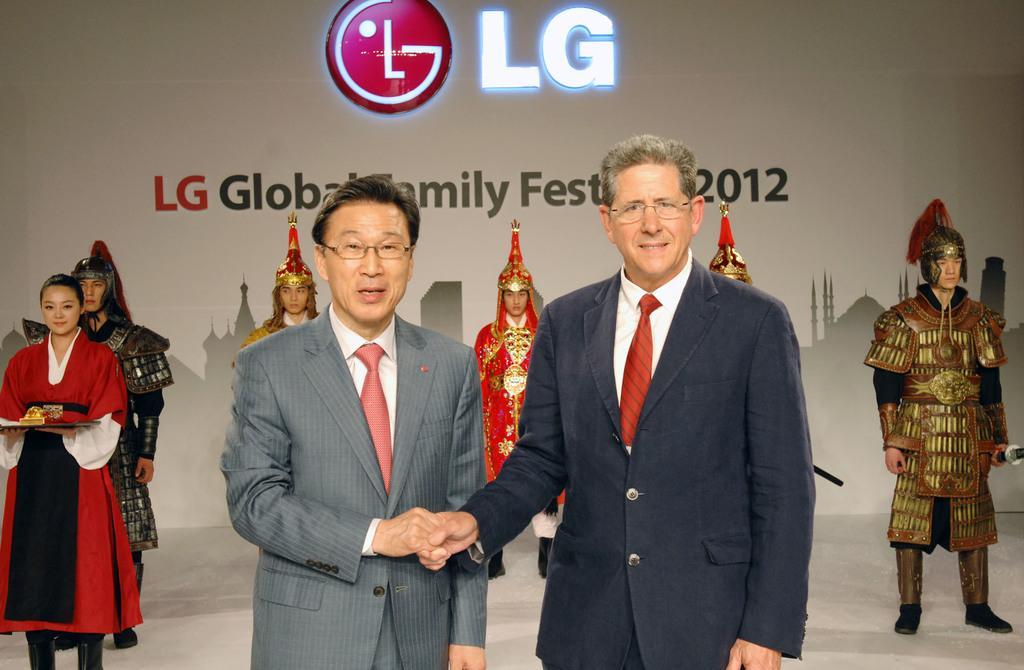Can you describe this image briefly? This picture describes about group of people, few people wore spectacles and few people wore costumes, in the background we can see a hoarding. 